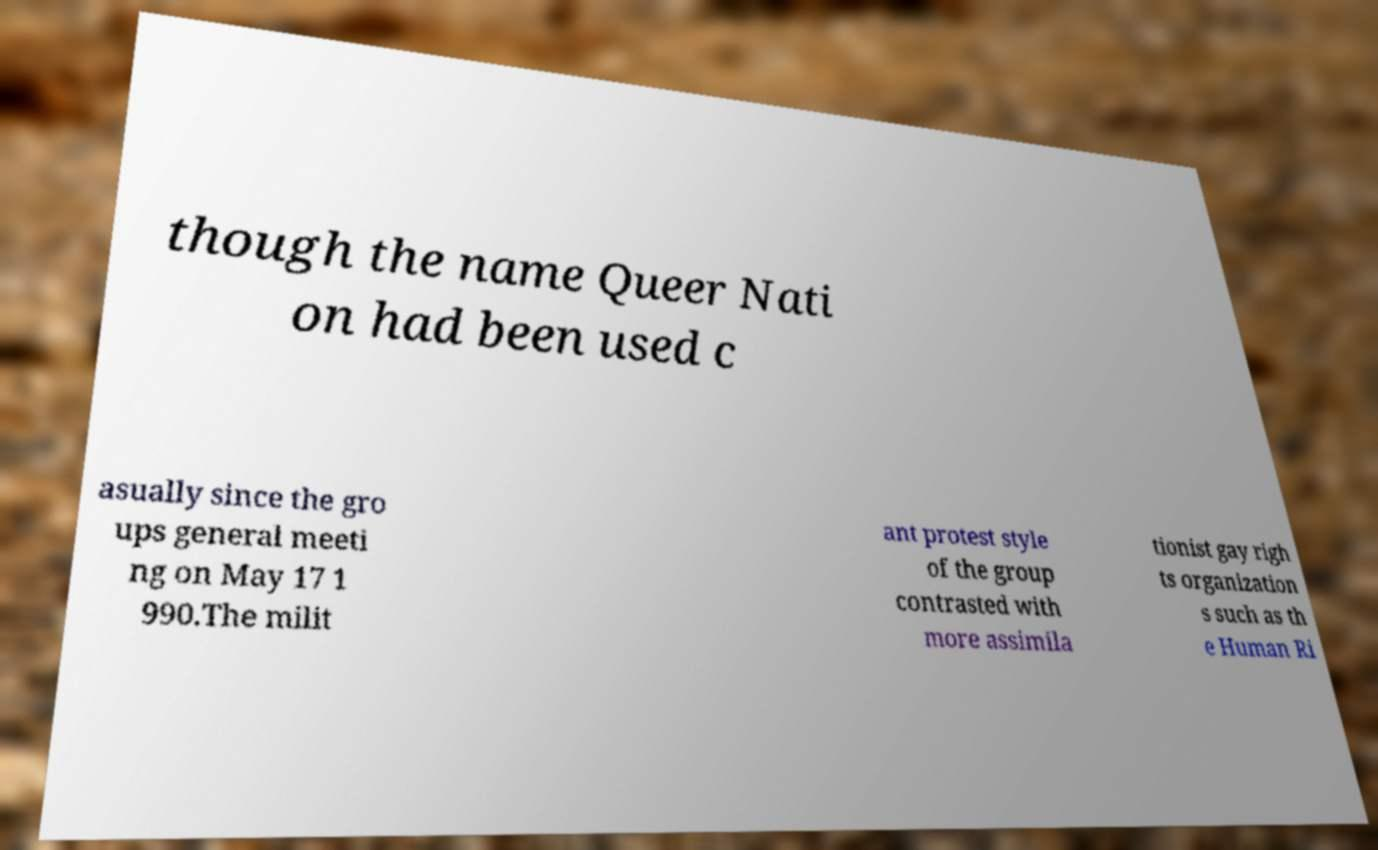There's text embedded in this image that I need extracted. Can you transcribe it verbatim? though the name Queer Nati on had been used c asually since the gro ups general meeti ng on May 17 1 990.The milit ant protest style of the group contrasted with more assimila tionist gay righ ts organization s such as th e Human Ri 